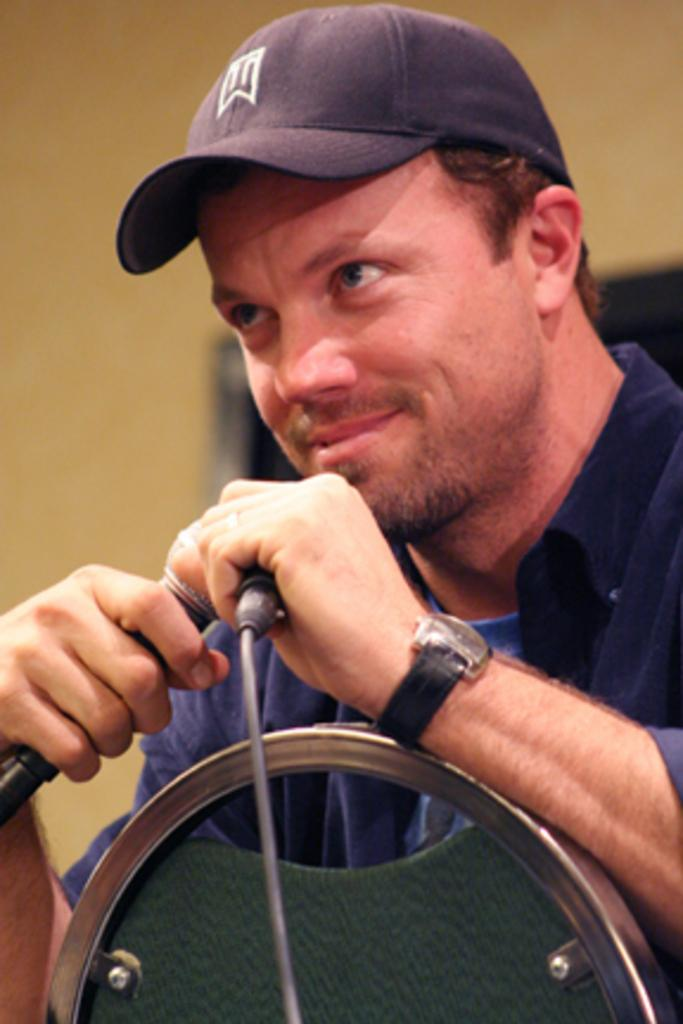What is the person in the image doing? The person is sitting. What can be seen on the person's head? The person is wearing a cap. What color is the shirt the person is wearing? The person is wearing a blue shirt. What object is the person holding? The person is holding a mic. What accessory is the person wearing on their wrist? The person is wearing a watch. What color is the wall in the background of the image? The wall in the background of the image is yellow. Can you tell me how many properties the person owns based on the image? There is no information about the person's properties in the image. Did the image capture an earthquake happening? There is no indication of an earthquake in the image. 